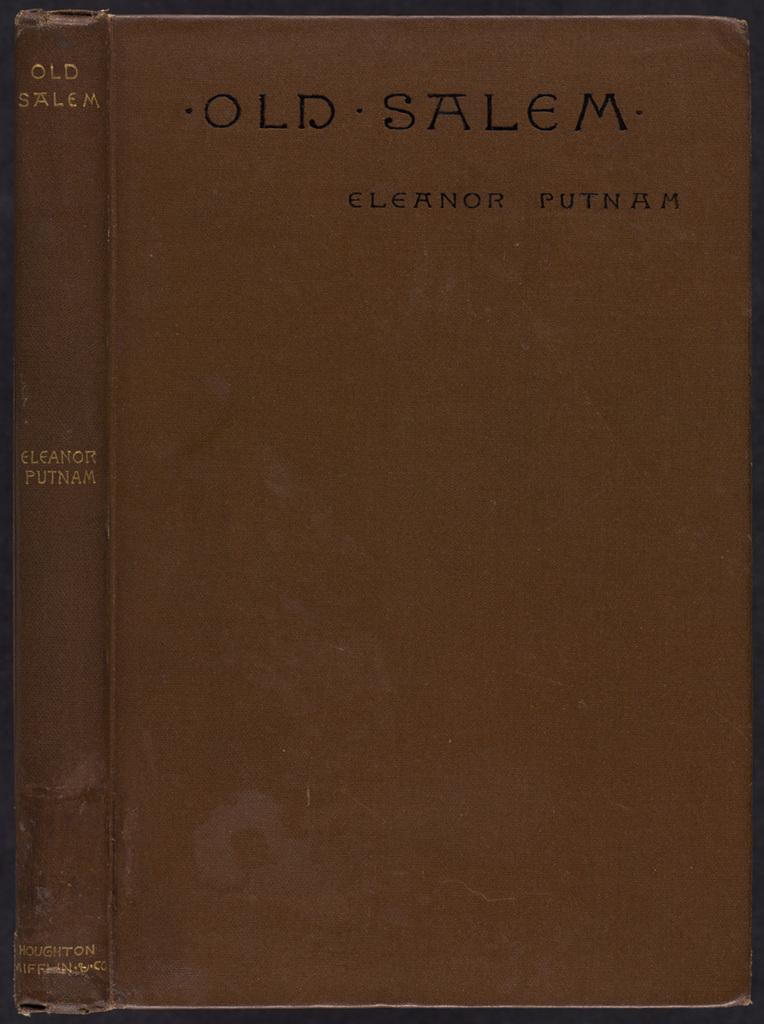<image>
Describe the image concisely. A book titled " Old Salem" by Eleanor Putnam. 